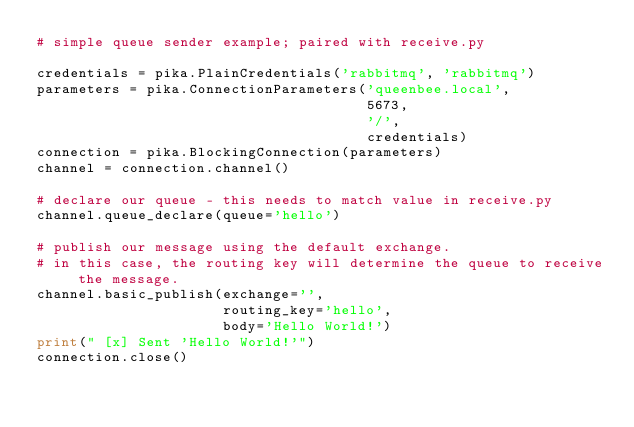<code> <loc_0><loc_0><loc_500><loc_500><_Python_># simple queue sender example; paired with receive.py

credentials = pika.PlainCredentials('rabbitmq', 'rabbitmq')
parameters = pika.ConnectionParameters('queenbee.local',
                                       5673,
                                       '/',
                                       credentials)
connection = pika.BlockingConnection(parameters)
channel = connection.channel()

# declare our queue - this needs to match value in receive.py
channel.queue_declare(queue='hello')

# publish our message using the default exchange.
# in this case, the routing key will determine the queue to receive the message.
channel.basic_publish(exchange='',
                      routing_key='hello',
                      body='Hello World!')
print(" [x] Sent 'Hello World!'")
connection.close()
</code> 